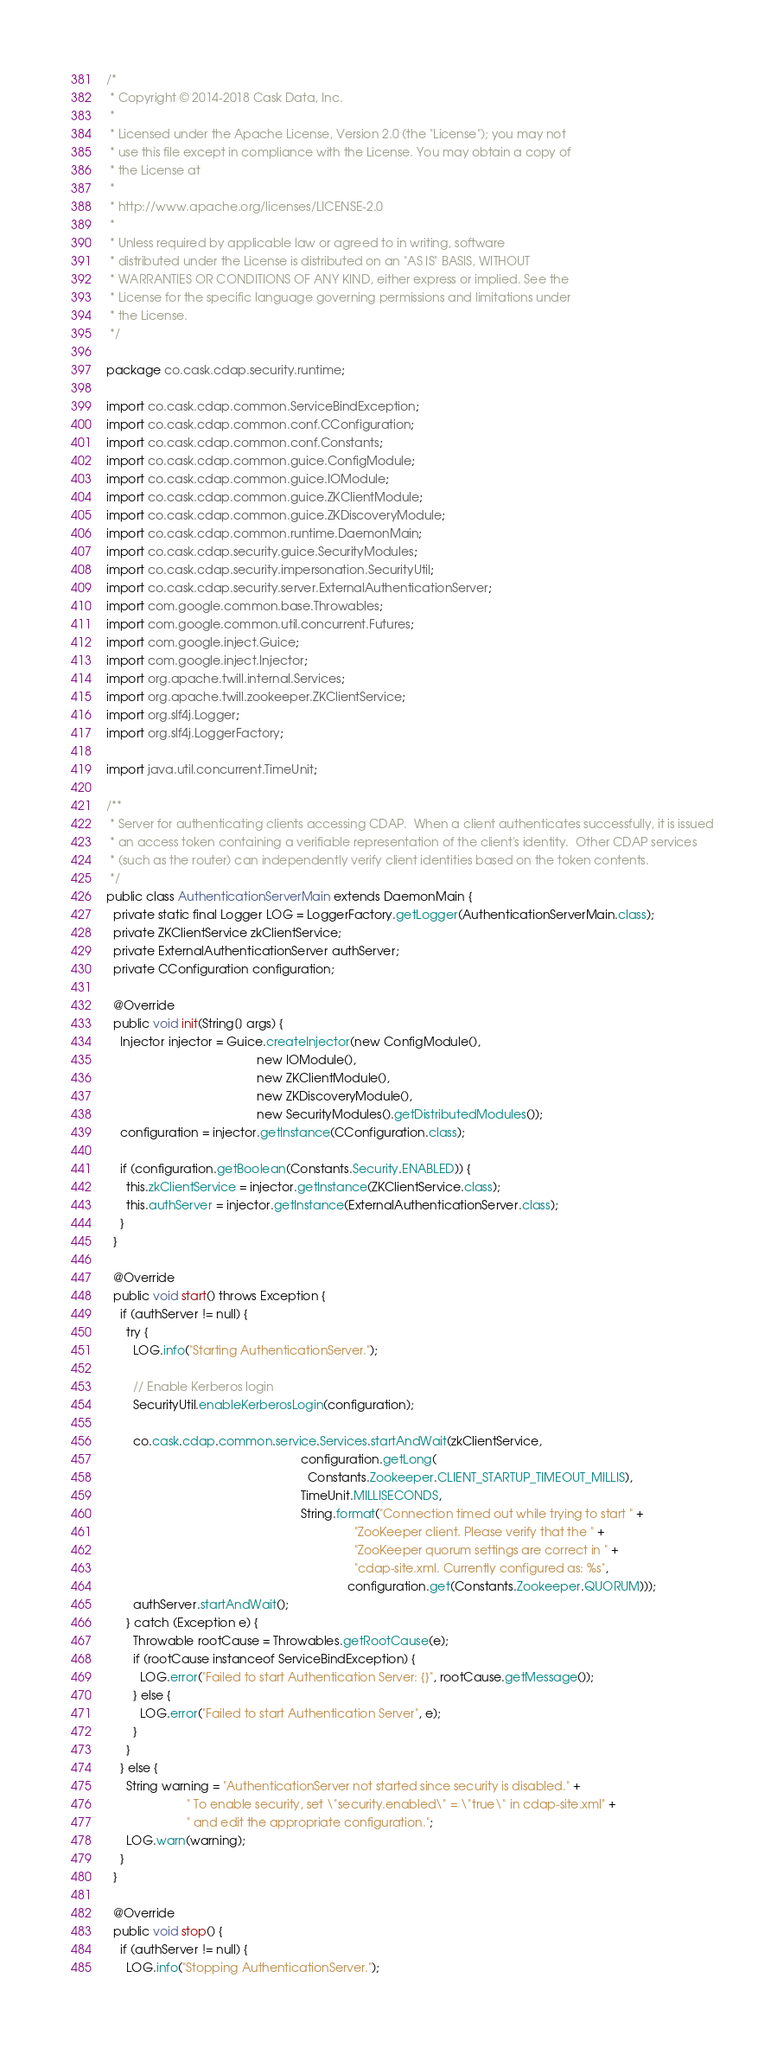Convert code to text. <code><loc_0><loc_0><loc_500><loc_500><_Java_>/*
 * Copyright © 2014-2018 Cask Data, Inc.
 *
 * Licensed under the Apache License, Version 2.0 (the "License"); you may not
 * use this file except in compliance with the License. You may obtain a copy of
 * the License at
 *
 * http://www.apache.org/licenses/LICENSE-2.0
 *
 * Unless required by applicable law or agreed to in writing, software
 * distributed under the License is distributed on an "AS IS" BASIS, WITHOUT
 * WARRANTIES OR CONDITIONS OF ANY KIND, either express or implied. See the
 * License for the specific language governing permissions and limitations under
 * the License.
 */

package co.cask.cdap.security.runtime;

import co.cask.cdap.common.ServiceBindException;
import co.cask.cdap.common.conf.CConfiguration;
import co.cask.cdap.common.conf.Constants;
import co.cask.cdap.common.guice.ConfigModule;
import co.cask.cdap.common.guice.IOModule;
import co.cask.cdap.common.guice.ZKClientModule;
import co.cask.cdap.common.guice.ZKDiscoveryModule;
import co.cask.cdap.common.runtime.DaemonMain;
import co.cask.cdap.security.guice.SecurityModules;
import co.cask.cdap.security.impersonation.SecurityUtil;
import co.cask.cdap.security.server.ExternalAuthenticationServer;
import com.google.common.base.Throwables;
import com.google.common.util.concurrent.Futures;
import com.google.inject.Guice;
import com.google.inject.Injector;
import org.apache.twill.internal.Services;
import org.apache.twill.zookeeper.ZKClientService;
import org.slf4j.Logger;
import org.slf4j.LoggerFactory;

import java.util.concurrent.TimeUnit;

/**
 * Server for authenticating clients accessing CDAP.  When a client authenticates successfully, it is issued
 * an access token containing a verifiable representation of the client's identity.  Other CDAP services
 * (such as the router) can independently verify client identities based on the token contents.
 */
public class AuthenticationServerMain extends DaemonMain {
  private static final Logger LOG = LoggerFactory.getLogger(AuthenticationServerMain.class);
  private ZKClientService zkClientService;
  private ExternalAuthenticationServer authServer;
  private CConfiguration configuration;

  @Override
  public void init(String[] args) {
    Injector injector = Guice.createInjector(new ConfigModule(),
                                             new IOModule(),
                                             new ZKClientModule(),
                                             new ZKDiscoveryModule(),
                                             new SecurityModules().getDistributedModules());
    configuration = injector.getInstance(CConfiguration.class);

    if (configuration.getBoolean(Constants.Security.ENABLED)) {
      this.zkClientService = injector.getInstance(ZKClientService.class);
      this.authServer = injector.getInstance(ExternalAuthenticationServer.class);
    }
  }

  @Override
  public void start() throws Exception {
    if (authServer != null) {
      try {
        LOG.info("Starting AuthenticationServer.");

        // Enable Kerberos login
        SecurityUtil.enableKerberosLogin(configuration);

        co.cask.cdap.common.service.Services.startAndWait(zkClientService,
                                                          configuration.getLong(
                                                            Constants.Zookeeper.CLIENT_STARTUP_TIMEOUT_MILLIS),
                                                          TimeUnit.MILLISECONDS,
                                                          String.format("Connection timed out while trying to start " +
                                                                          "ZooKeeper client. Please verify that the " +
                                                                          "ZooKeeper quorum settings are correct in " +
                                                                          "cdap-site.xml. Currently configured as: %s",
                                                                        configuration.get(Constants.Zookeeper.QUORUM)));
        authServer.startAndWait();
      } catch (Exception e) {
        Throwable rootCause = Throwables.getRootCause(e);
        if (rootCause instanceof ServiceBindException) {
          LOG.error("Failed to start Authentication Server: {}", rootCause.getMessage());
        } else {
          LOG.error("Failed to start Authentication Server", e);
        }
      }
    } else {
      String warning = "AuthenticationServer not started since security is disabled." +
                        " To enable security, set \"security.enabled\" = \"true\" in cdap-site.xml" +
                        " and edit the appropriate configuration.";
      LOG.warn(warning);
    }
  }

  @Override
  public void stop() {
    if (authServer != null) {
      LOG.info("Stopping AuthenticationServer.");</code> 